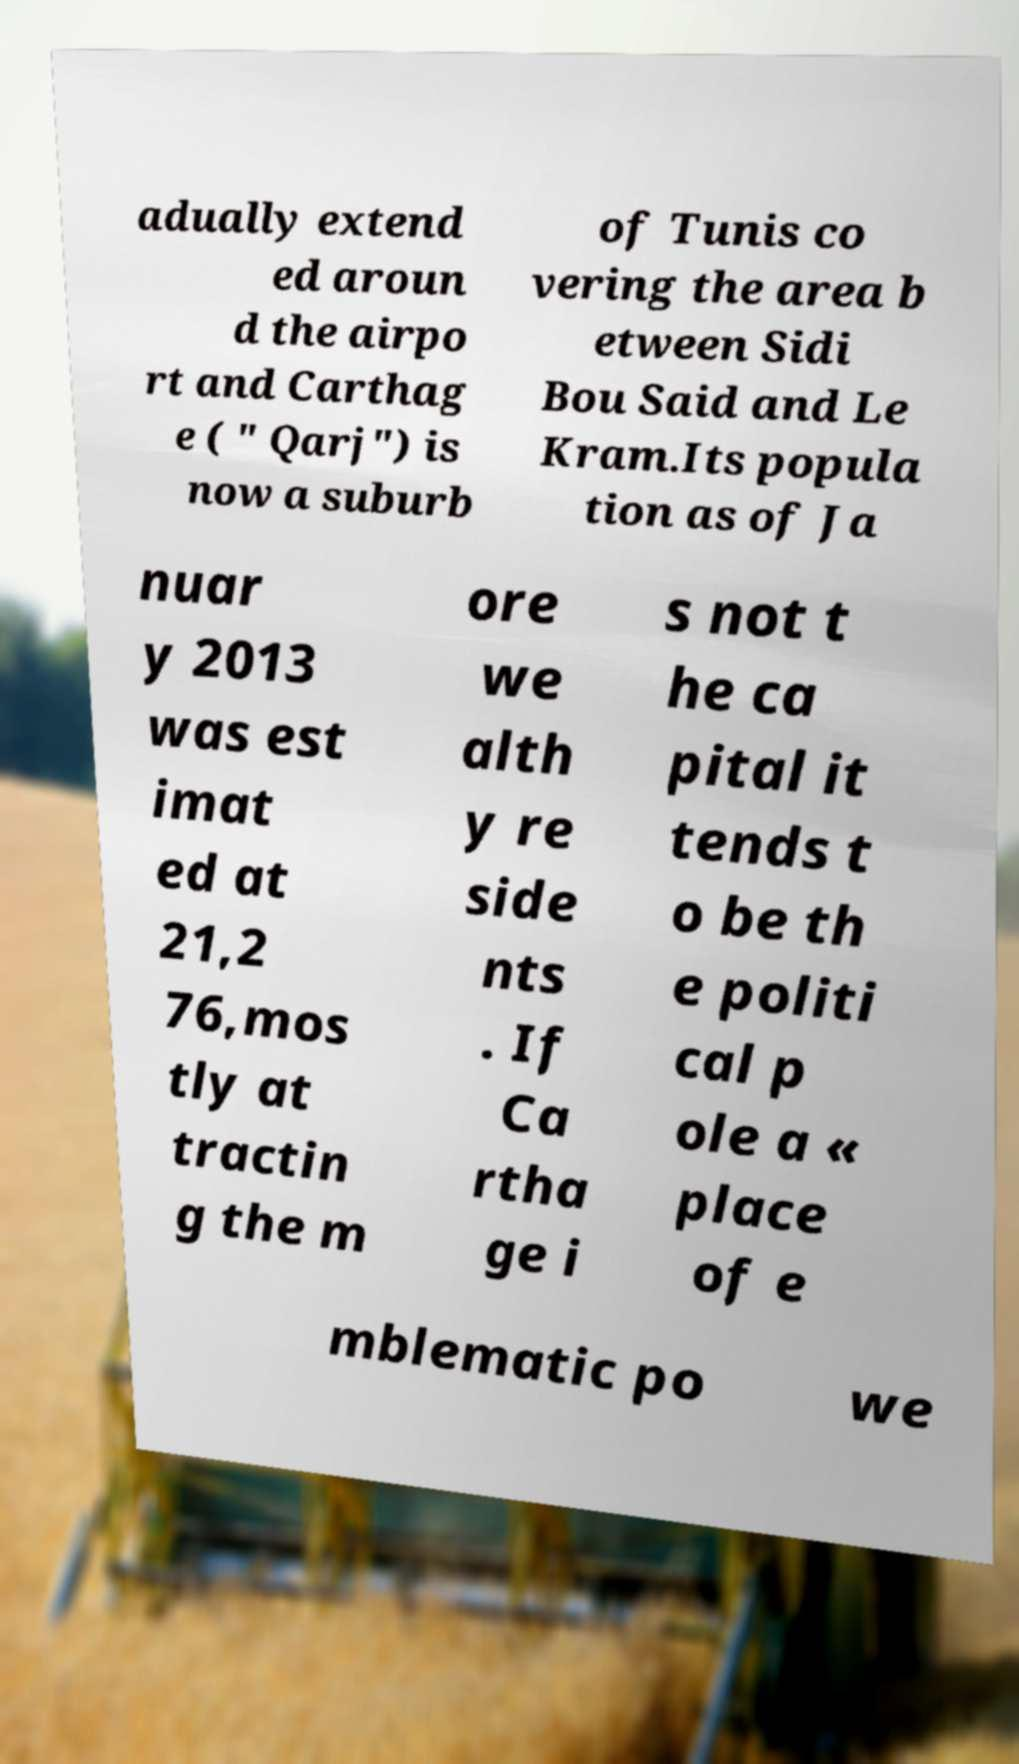Can you read and provide the text displayed in the image?This photo seems to have some interesting text. Can you extract and type it out for me? adually extend ed aroun d the airpo rt and Carthag e ( " Qarj") is now a suburb of Tunis co vering the area b etween Sidi Bou Said and Le Kram.Its popula tion as of Ja nuar y 2013 was est imat ed at 21,2 76,mos tly at tractin g the m ore we alth y re side nts . If Ca rtha ge i s not t he ca pital it tends t o be th e politi cal p ole a « place of e mblematic po we 